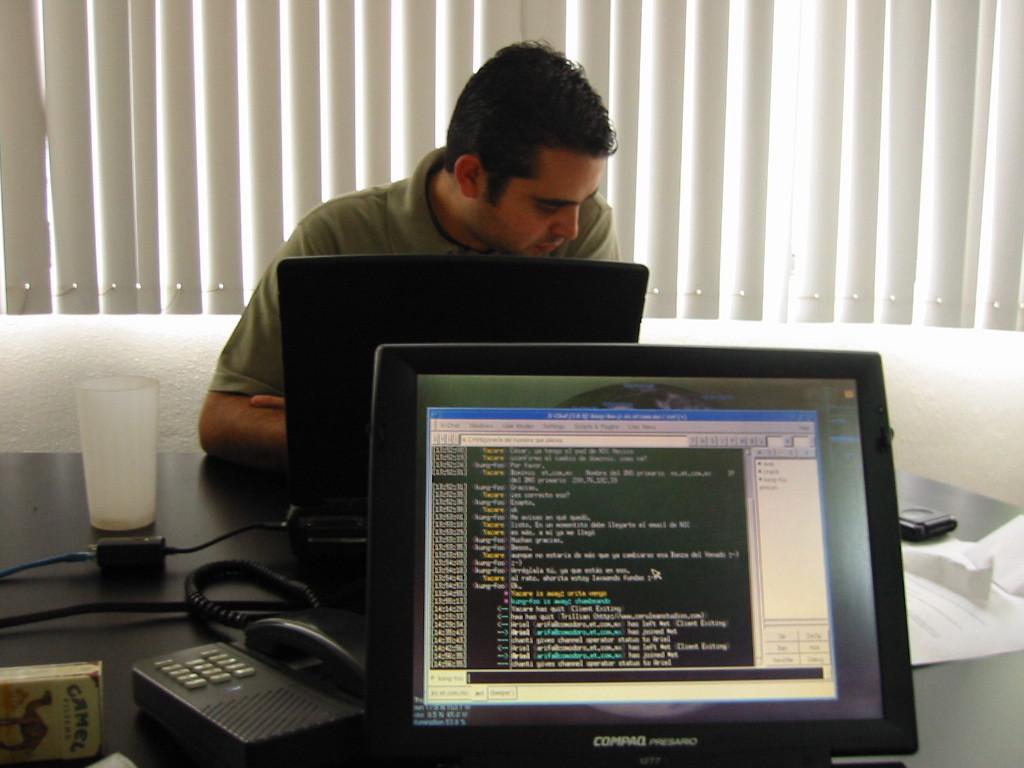What type of computer is that?
Offer a very short reply. Compaq. What brand of cigarettes is in the bottom left hand corner?
Give a very brief answer. Camel. 